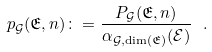Convert formula to latex. <formula><loc_0><loc_0><loc_500><loc_500>p _ { \mathcal { G } } ( \mathfrak { E } , n ) \colon = \frac { P _ { \mathcal { G } } ( \mathfrak { E } , n ) } { \alpha _ { \mathcal { G } , \dim ( \mathfrak { E } ) } ( \mathcal { E } ) } \ .</formula> 